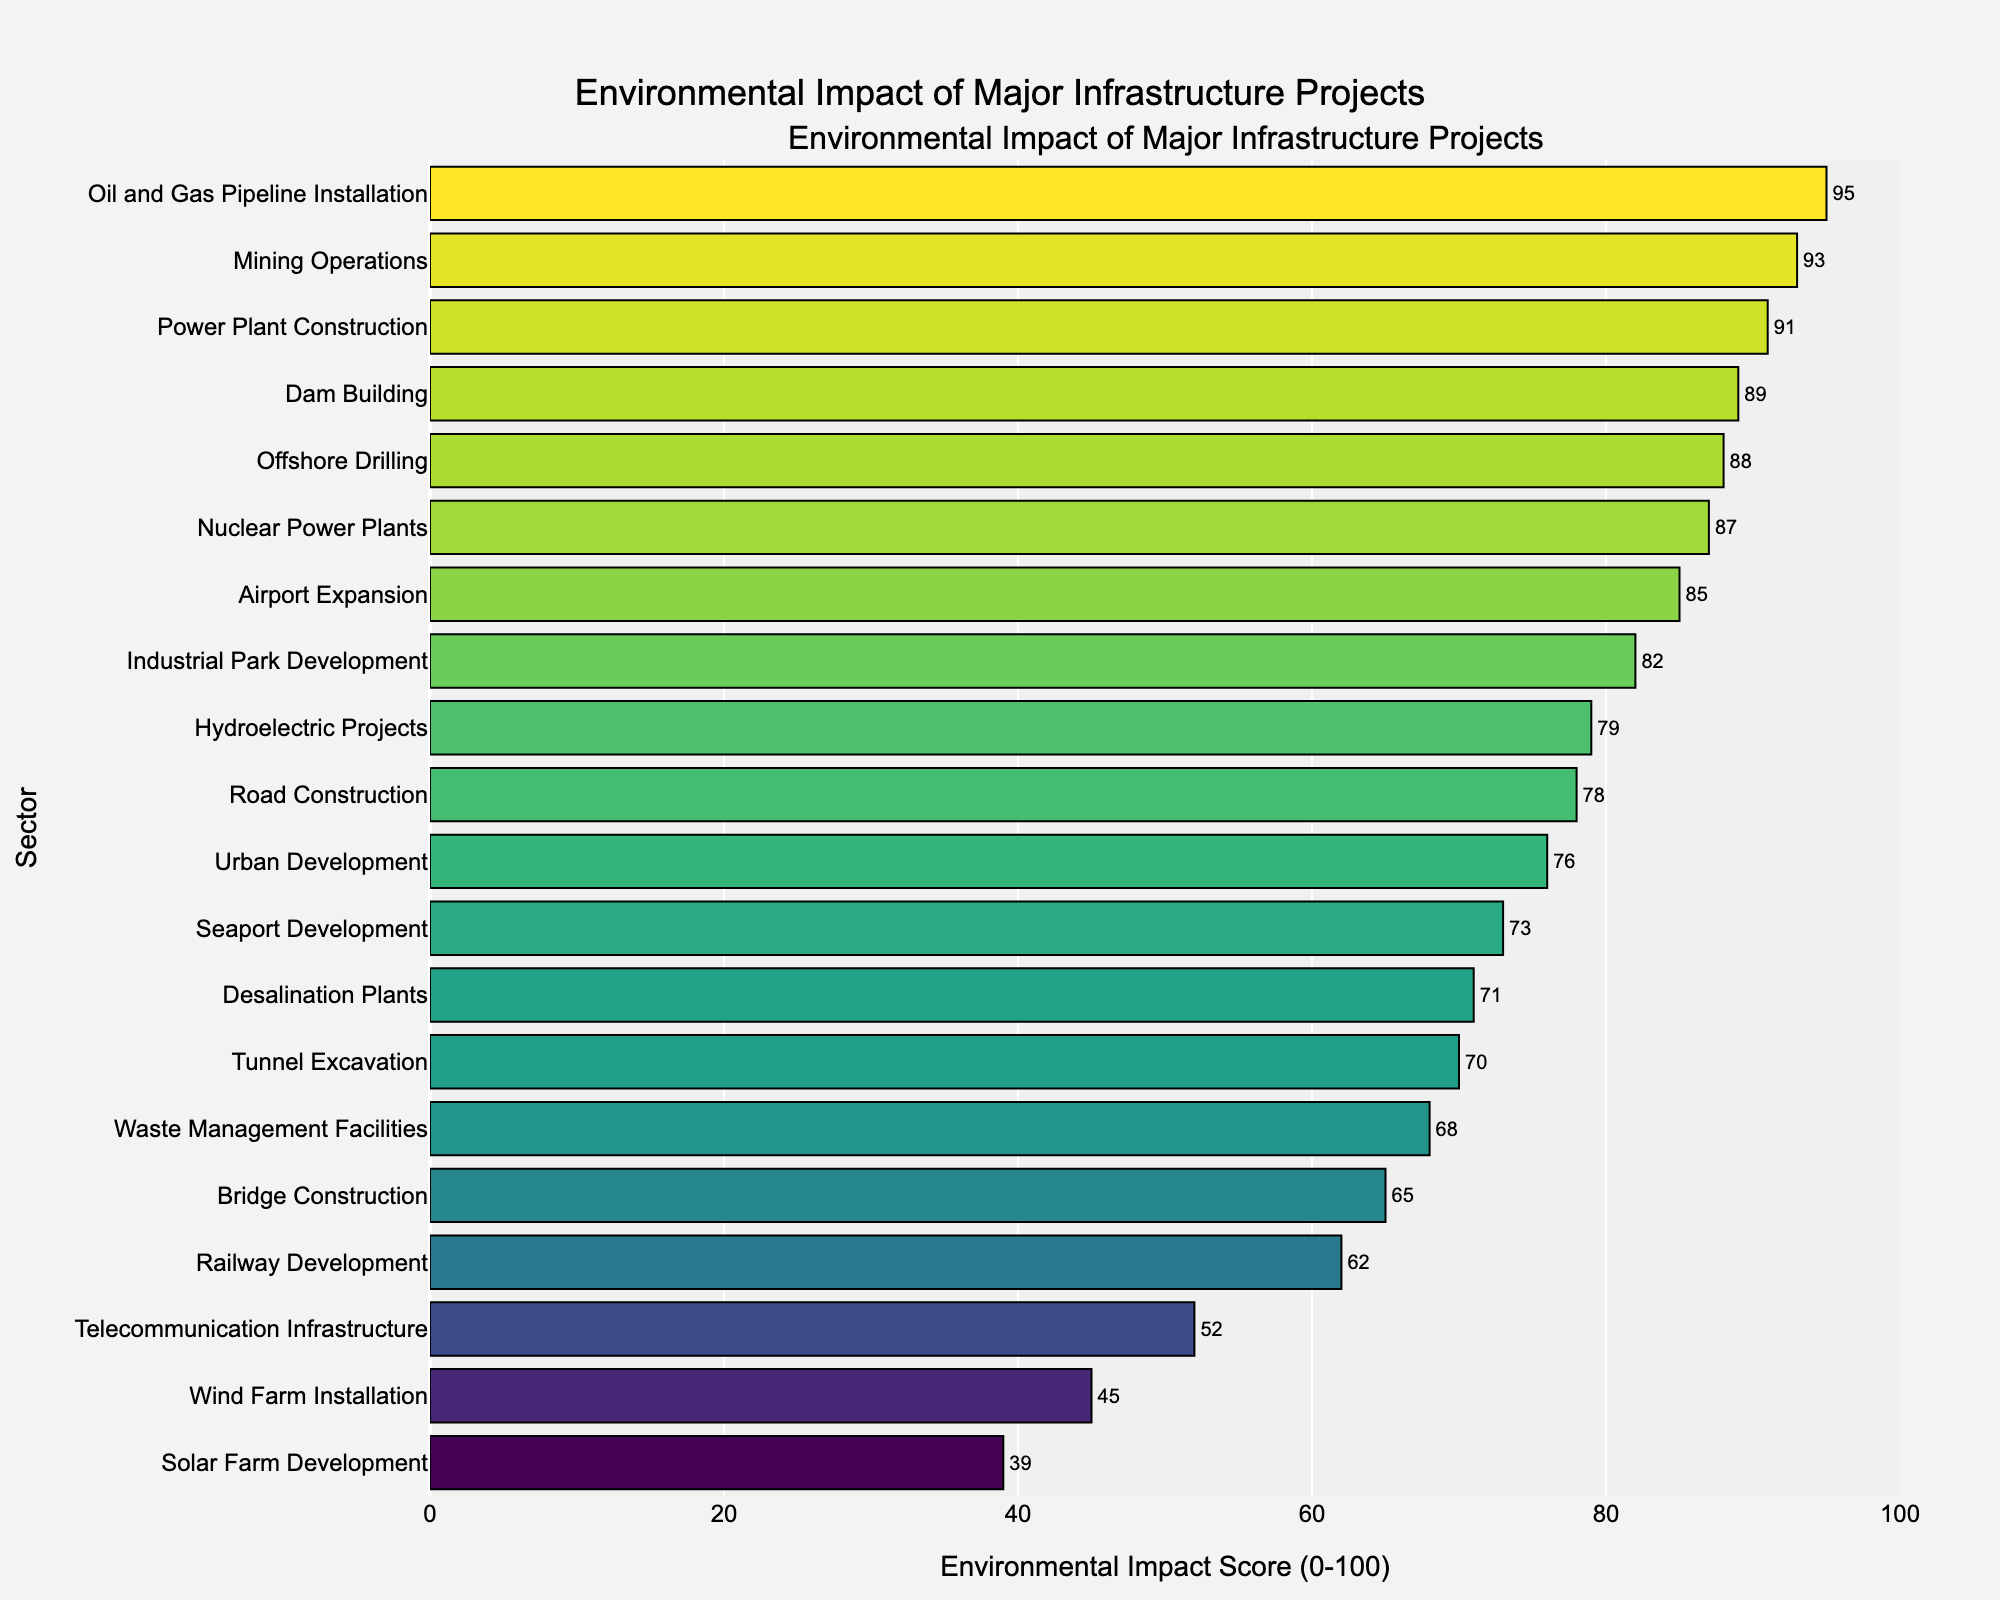Which sector has the highest environmental impact score? Check the bar chart for the sector with the longest bar. "Oil and Gas Pipeline Installation" has the highest score.
Answer: Oil and Gas Pipeline Installation Which sector has the lowest environmental impact score? Look for the bar with the smallest length. "Solar Farm Development" has the lowest score.
Answer: Solar Farm Development What is the difference in the environmental impact scores between "Power Plant Construction" and "Telecommunication Infrastructure"? Find the impact scores for both sectors and subtract the smaller one from the larger: 91 (Power Plant Construction) - 52 (Telecommunication Infrastructure) = 39.
Answer: 39 What is the average environmental impact score of the sectors "Mining Operations", "Offshore Drilling", and "Nuclear Power Plants"? Add the impact scores of the three sectors and divide by 3: (93 + 88 + 87) / 3 = 89.33.
Answer: 89.33 Which sector falls in the middle (median) when the environmental impact scores are sorted in ascending order? Sort the scores and find the middle value. After sorting, "Hydroelectric Projects" is the median value.
Answer: Hydroelectric Projects Are there more sectors with an environmental impact score above 80 or below 80? Count the number of sectors above 80 and below 80. There are seven sectors above 80 and thirteen sectors below 80.
Answer: Below 80 Compare the environmental impact scores of "Road Construction" and "Railway Development". Which sector has a higher score? Look at the bars for each sector and compare their lengths. "Road Construction" has a score of 78, while "Railway Development" has a score of 62.
Answer: Road Construction What is the combined environmental impact score of "Airport Expansion", "Seaport Development", and "Urban Development"? Add the scores of the three sectors: 85 + 73 + 76 = 234.
Answer: 234 How many sectors have environmental impact scores greater than or equal to 70 but less than 90? Count the qualifying sectors by observing the bar lengths within this range. There are nine sectors within this range.
Answer: 9 What is the range (difference between the highest and lowest scores) of the environmental impact scores? Subtract the smallest score from the largest score: 95 (highest) - 39 (lowest) = 56.
Answer: 56 